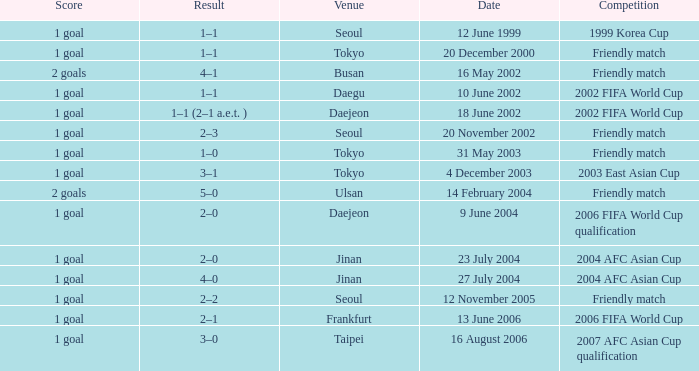What was the specific competition that transpired on july 27th, 2004? 2004 AFC Asian Cup. 